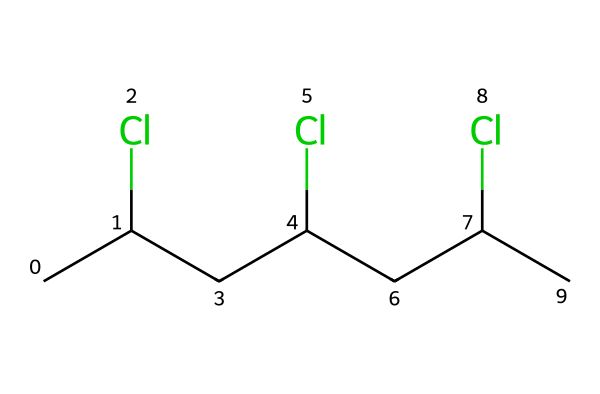What is the total number of chlorine atoms in this chemical? By examining the SMILES representation, we see there are three occurrences of "(Cl)", which indicates three chlorine atoms are present in the structure.
Answer: 3 How many carbon atoms are there in this molecule? The SMILES representation shows "CC(Cl)CC(Cl)CC(Cl)C", which includes a total of six "C" symbols, indicating that there are six carbon atoms in the molecule.
Answer: 6 What is the primary type of bonds present in this chemical? In the SMILES, there are no indicators of double or triple bonds, and since it consists mainly of carbon and chlorine, it primarily has single (sigma) bonds.
Answer: single bonds What is the molecular shape of this polymer? Given that it consists of a chain of carbon atoms with chlorine atoms attached, the molecular shape is likely to be linear or slightly branched, typical for aliphatic compounds.
Answer: linear What impact could this polymer have on the environment? The presence of chlorine atoms suggests that the polymer could be persistent in the environment, potentially leading to issues like toxicity and bioaccumulation.
Answer: toxic What type of polymer could this compound represent in yoga mats? The structure likely represents a type of chlorinated polymer often used in manufacturing, such as PVC, known for its durability and flexibility, which are desirable characteristics for yoga mats.
Answer: PVC What is a potential drawback of using this chemical in yoga mats? Chlorinated polymers like this one can release harmful substances when burned, making disposal environmentally problematic and raising concerns about sustainability.
Answer: harmful substances 